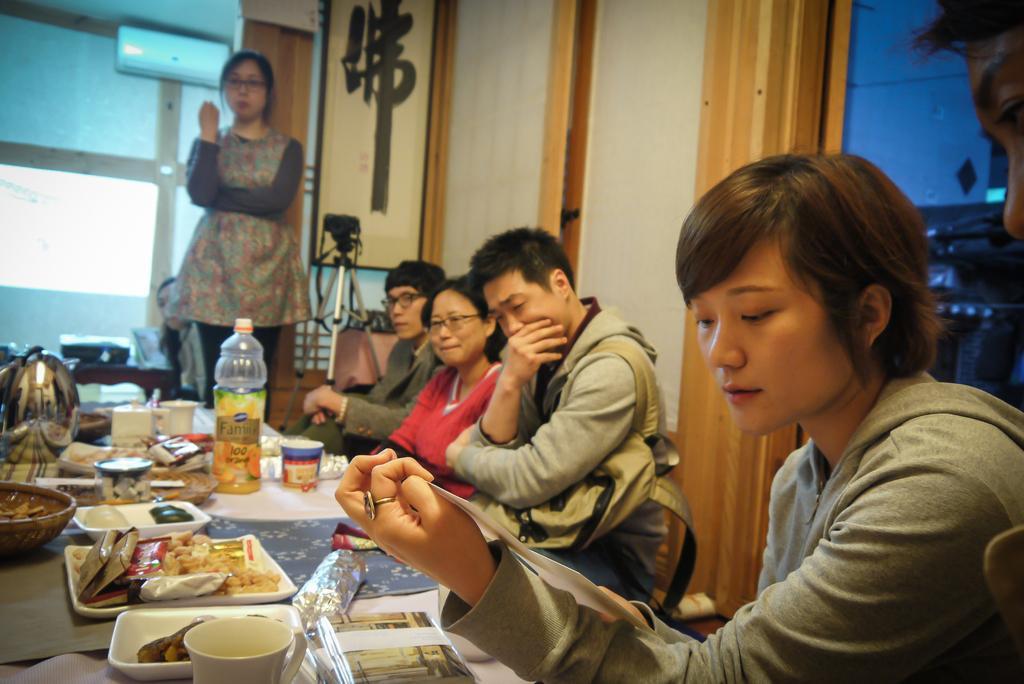Please provide a concise description of this image. In this picture there are group of persons sitting. In the front there is a table, on the table there is a bottle, there is a cup, and there is food on the plate. in the background there is a woman standing, behind the woman there is a wall and on the wall there is an a/c. On the right side in the front there is a woman holding a paper in her hand and looking at it. 